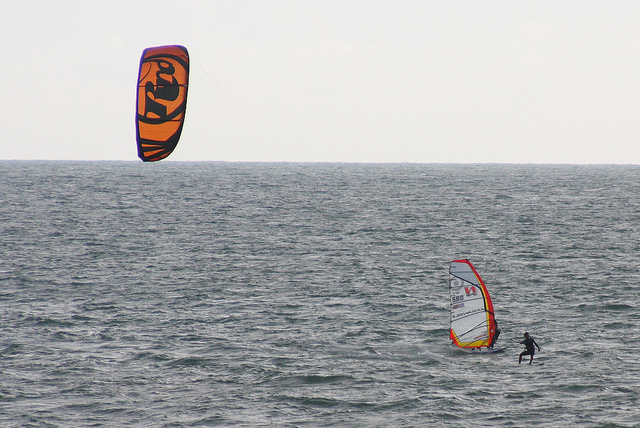Describe a scenario where these individuals are preparing for an upcoming competition. Alex and Jamie are gearing up for the annual Coastal Water Sports Competition. Weeks of intense training culminate in this moment. Alex fine-tunes his windsurfing techniques, perfecting his speed and maneuverability, while Jamie practices daring twists and turns to showcase his parasailing skills. They meticulously check their gear, ensuring every piece is in peak condition. The anticipation builds as they encourage each other, sharing techniques and strategies. On the day of the competition, they stand side by side, ready to take on the waves and wind, united by their passion and determination. What might the individuals feel right after this thrilling experience in the ocean? After their thrilling experience in the ocean, the individuals are likely to feel a rush of exhilaration and accomplishment. Their bodies might be tired but invigorated, their minds clear and refreshed. There's a sense of satisfaction from having faced the elements and mastered their respective sports. They feel a profound connection to the sea and a deep appreciation for the beauty and power of nature. 